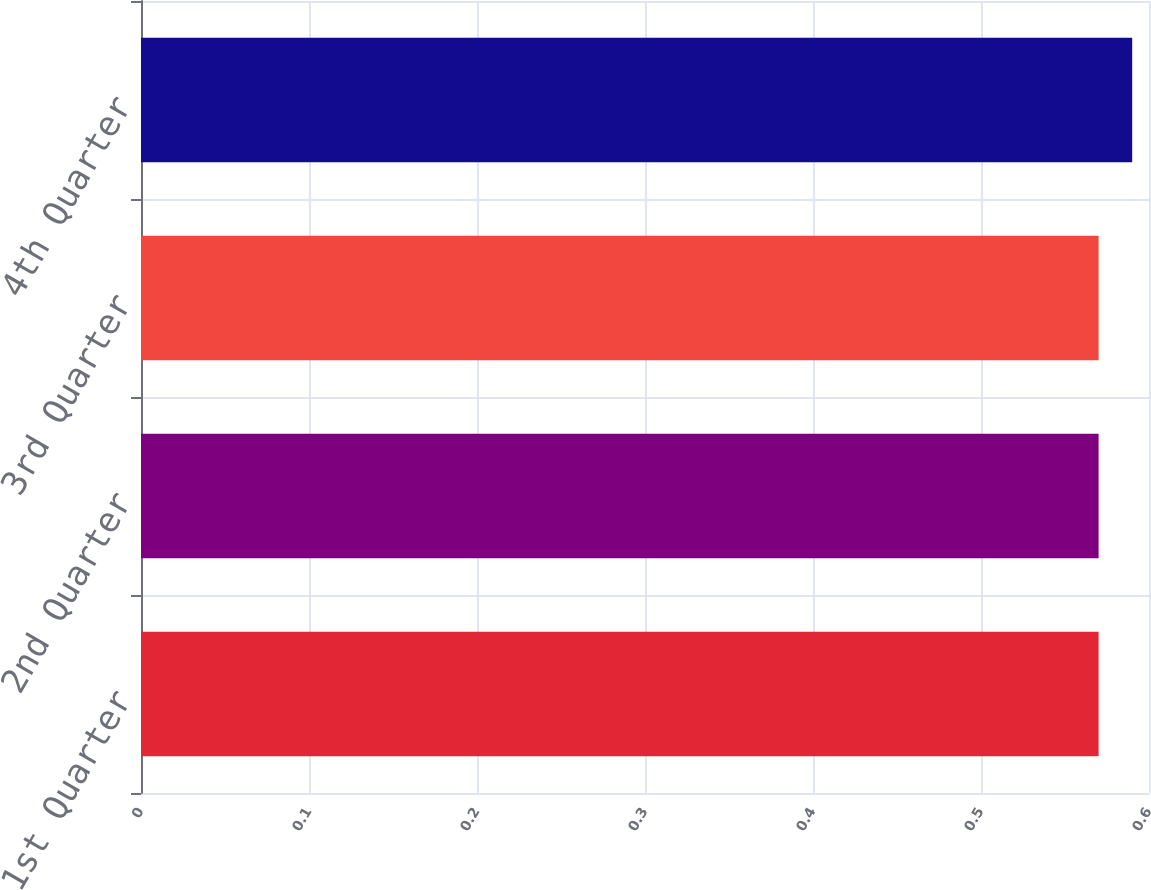Convert chart to OTSL. <chart><loc_0><loc_0><loc_500><loc_500><bar_chart><fcel>1st Quarter<fcel>2nd Quarter<fcel>3rd Quarter<fcel>4th Quarter<nl><fcel>0.57<fcel>0.57<fcel>0.57<fcel>0.59<nl></chart> 